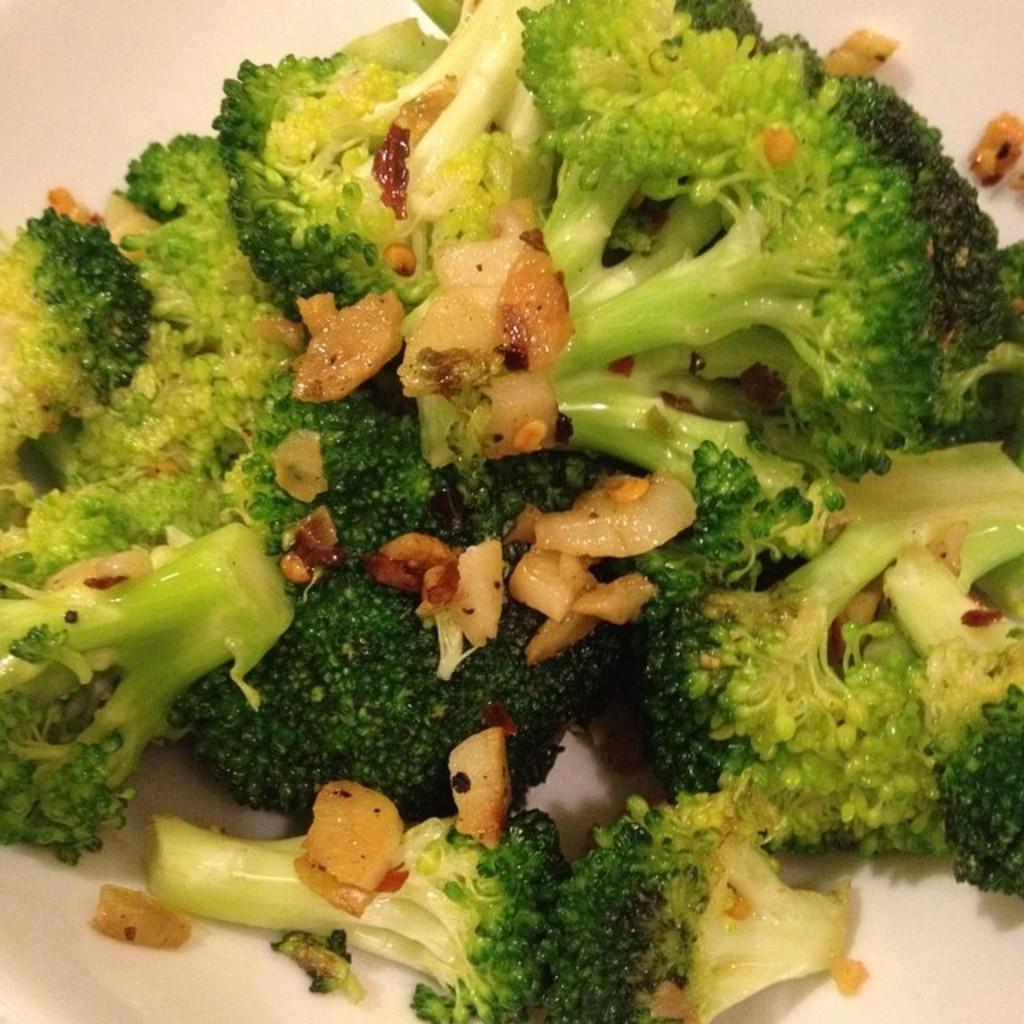Describe this image in one or two sentences. In this picture there is a broccoli and some other objects placed on a white surface. 